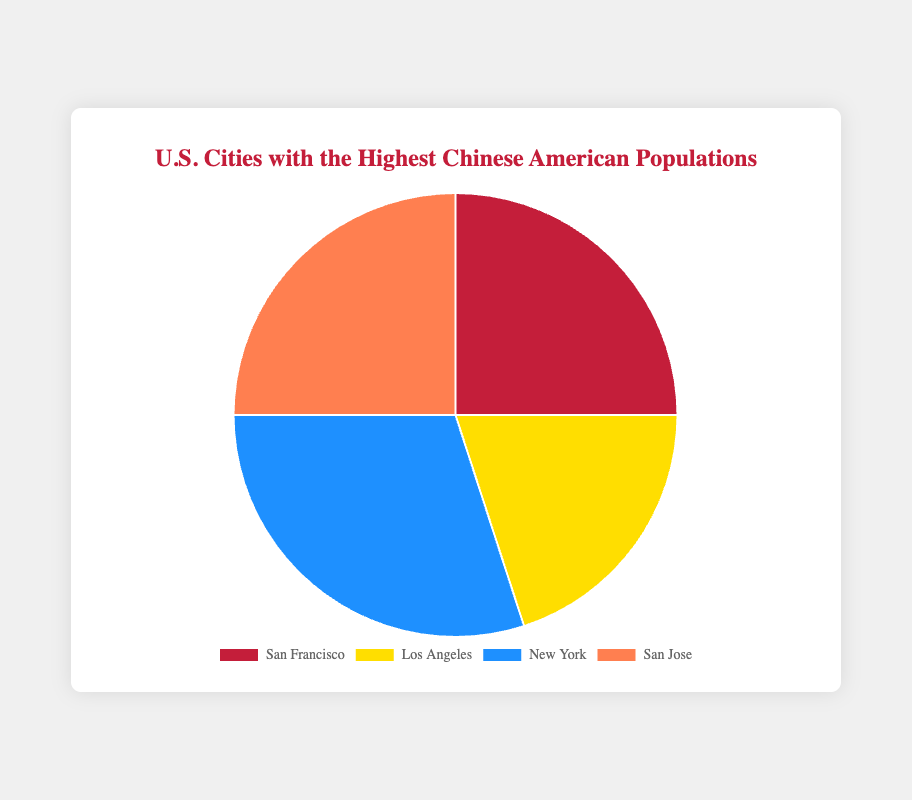Which city has the highest percentage of Chinese American population? By observing the pie chart, we look for the segment with the largest area. The city labeled "New York" has the largest percentage, which is 30%.
Answer: New York What is the combined percentage of Chinese American populations in San Francisco and San Jose? To find the combined percentage, we add the percentages of San Francisco (25%) and San Jose (25%). The result is 25% + 25% = 50%.
Answer: 50% Which two cities have the same percentage of Chinese American population? By identifying the segments with identical sizes, we see that San Francisco and San Jose each have a population percentage of 25%.
Answer: San Francisco and San Jose How much smaller is the percentage of Chinese American population in Los Angeles compared to New York? We need to subtract the percentage of Los Angeles, which is 20%, from the percentage of New York, which is 30%. 30% - 20% = 10%.
Answer: 10% What is the difference in population percentage between San Francisco and Los Angeles? To determine the difference, subtract the percentage of Los Angeles (20%) from the percentage of San Francisco (25%). 25% - 20% = 5%.
Answer: 5% What percentage of the Chinese American population is not in New York City? To find this, subtract the New York percentage (30%) from 100%. 100% - 30% = 70%.
Answer: 70% If the chart sections are colored red, yellow, blue, and orange, what color represents New York? Observing the color that corresponds to New York's segment, it is the one with the largest area. The blue section represents New York.
Answer: Blue 